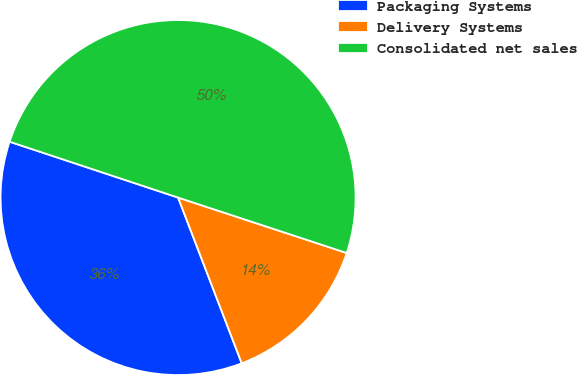Convert chart to OTSL. <chart><loc_0><loc_0><loc_500><loc_500><pie_chart><fcel>Packaging Systems<fcel>Delivery Systems<fcel>Consolidated net sales<nl><fcel>35.93%<fcel>14.11%<fcel>49.96%<nl></chart> 